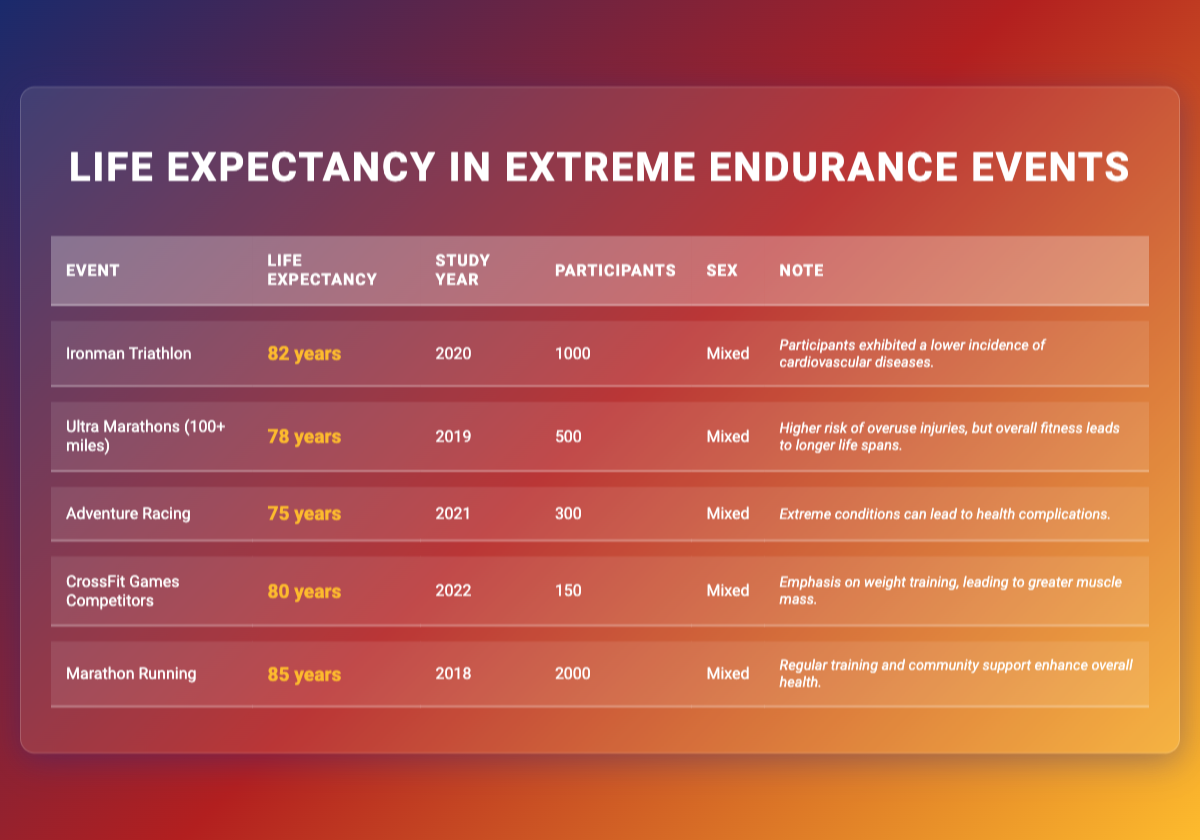What is the average life expectancy for participants in Ironman Triathlons? The table provides a specific life expectancy for Ironman Triathlon participants, which is listed as 82 years in the respective row.
Answer: 82 years How many participants were in the study for Ultra Marathons? The number of participants for Ultra Marathons is clearly stated in the table as 500, visible in the corresponding row.
Answer: 500 Is the average life expectancy for Adventure Racing higher than for CrossFit Games Competitors? Adventure Racing has an average life expectancy of 75 years while CrossFit Games Competitors have an average of 80 years. Since 80 is greater than 75, the answer is no.
Answer: No What is the difference in life expectancy between Marathon Running and Ultra Marathons? The life expectancy for Marathon Running is 85 years, and for Ultra Marathons, it is 78 years. To find the difference, subtract 78 from 85, which gives 7 years.
Answer: 7 years What percentage of participants in the Ironman Triathlon reported lower cardiovascular disease incidences? The life expectancy data does not provide a percentage, but it states that participants exhibited a lower incidence of cardiovascular diseases. Thus, no specific percentage can be derived from the given note, making it an unknown value.
Answer: Unknown Which endurance event has the highest average life expectancy? Upon examining the life expectancy values in the table, Marathon Running has the highest average life expectancy at 85 years.
Answer: Marathon Running In what year was the lowest average life expectancy recorded, and for which event? Looking through the table, Adventure Racing has the lowest average life expectancy of 75 years, recorded in the year 2021.
Answer: 2021, Adventure Racing If we consider only the events with an average life expectancy of 80 years or higher, how many participants are there in total? The events with life expectancies of 80 years or more are Ironman Triathlon (1000 participants), CrossFit Games Competitors (150 participants), and Marathon Running (2000 participants). Adding these gives: 1000 + 150 + 2000 = 3150 participants total.
Answer: 3150 participants Does participation in Ultra Marathons lead to longer life spans despite higher overuse injury risks? The note for Ultra Marathons indicates that, despite the higher risk of overuse injuries, overall fitness tends to lead to longer life spans among participants. Thus, this statement is true.
Answer: Yes 